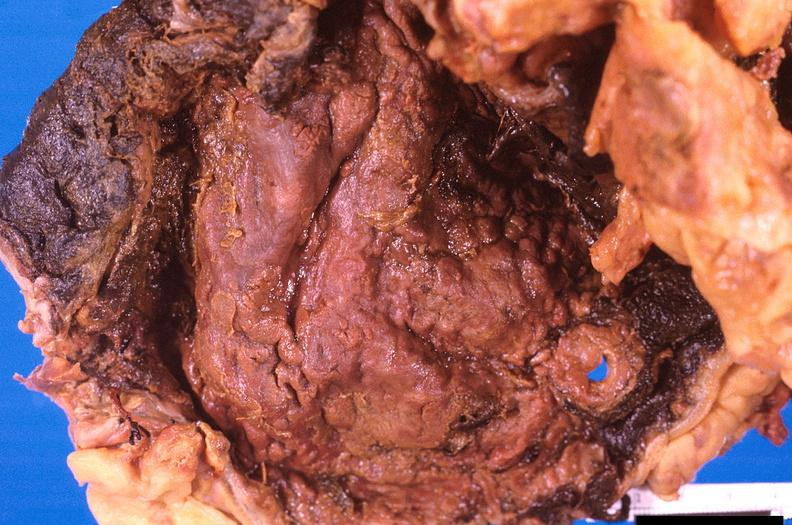s another fiber other frame present?
Answer the question using a single word or phrase. No 